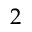Convert formula to latex. <formula><loc_0><loc_0><loc_500><loc_500>2</formula> 